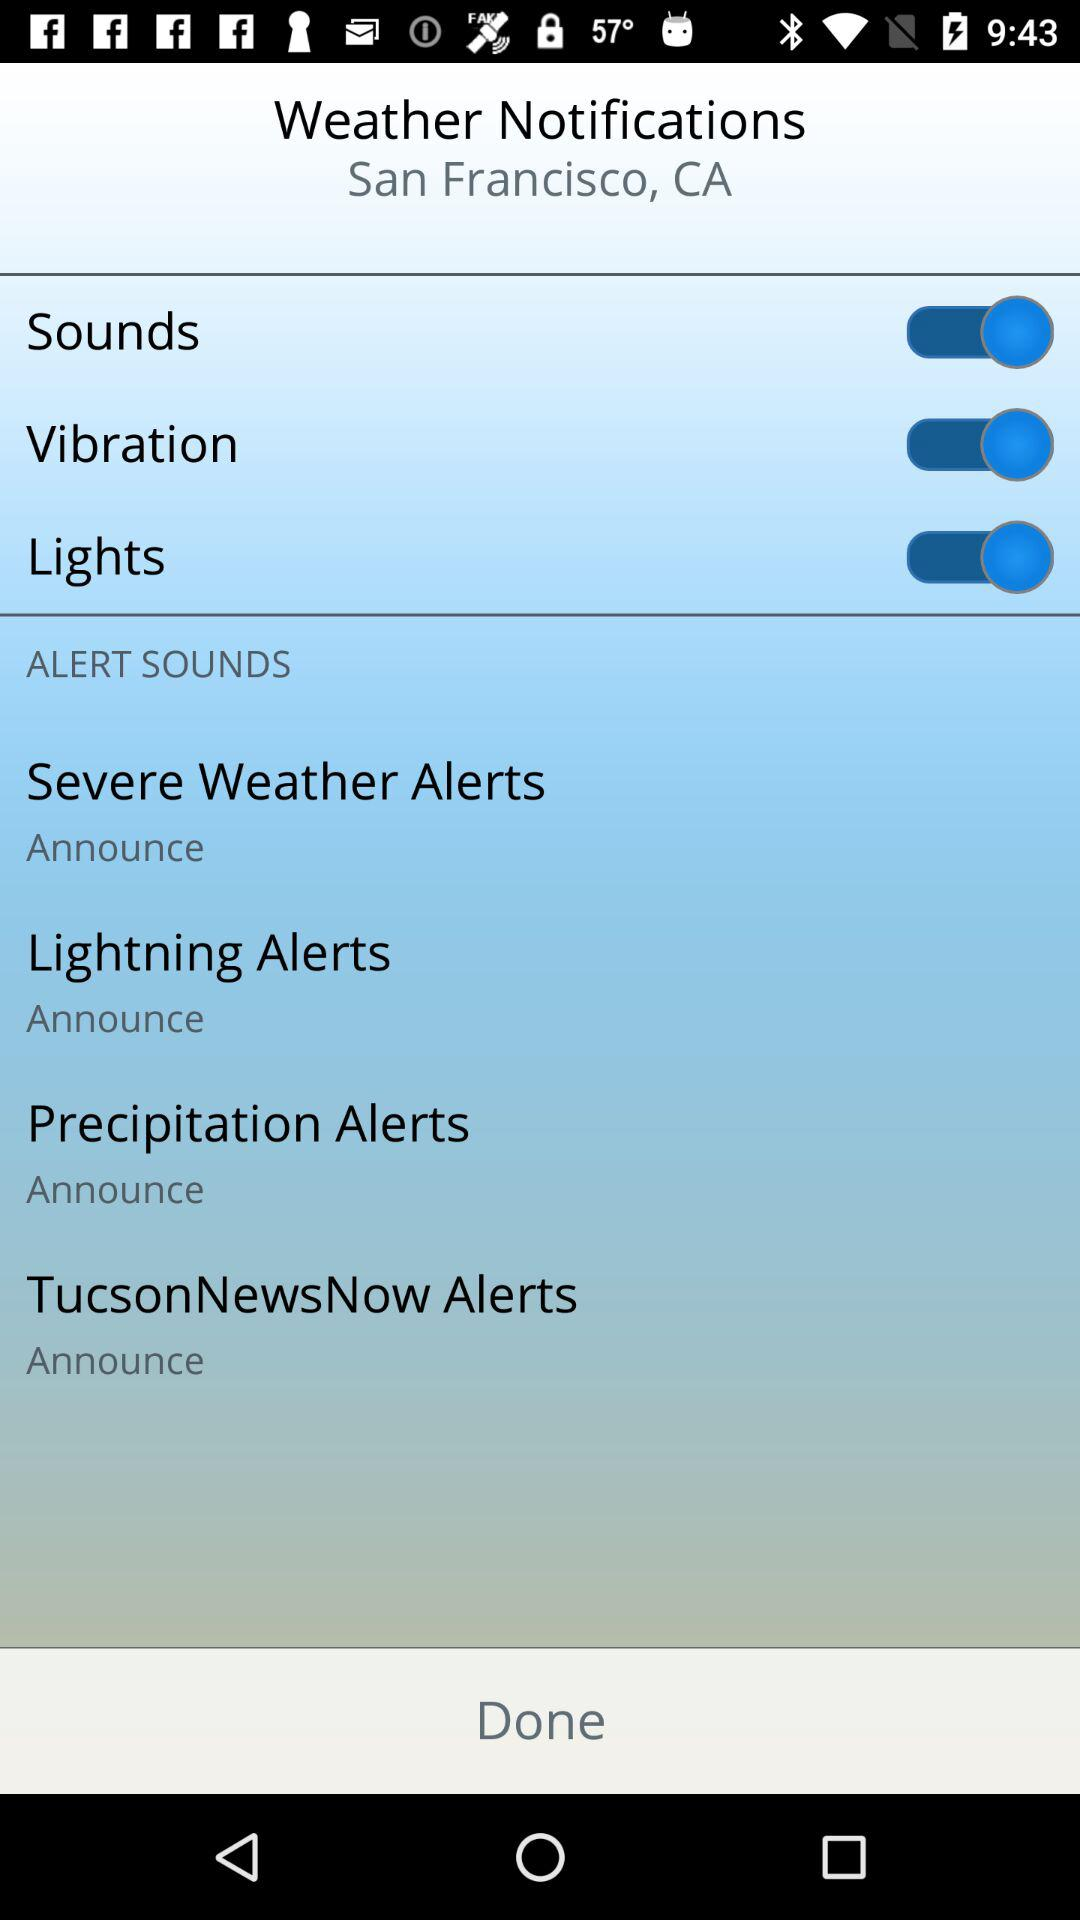What is the given location? The given location is San Francisco, CA. 